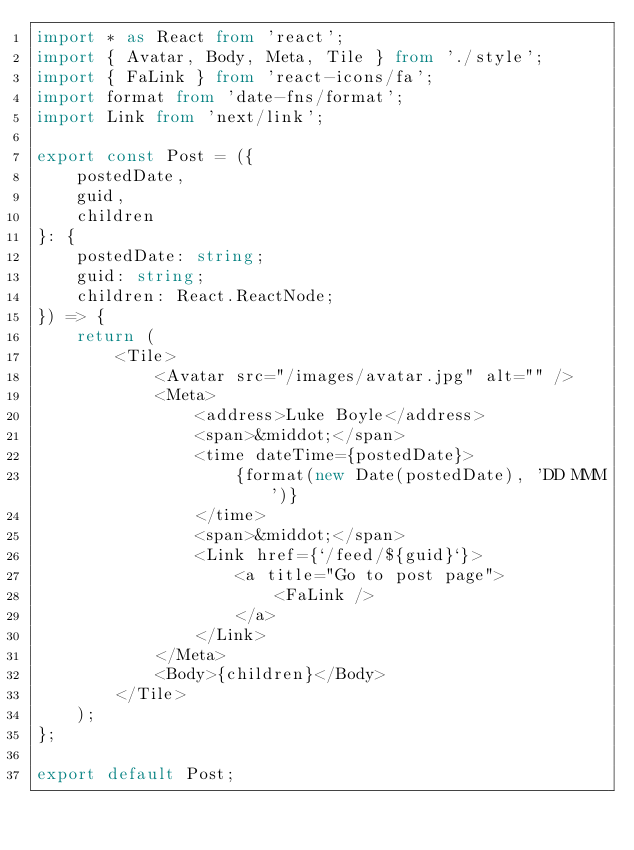<code> <loc_0><loc_0><loc_500><loc_500><_TypeScript_>import * as React from 'react';
import { Avatar, Body, Meta, Tile } from './style';
import { FaLink } from 'react-icons/fa';
import format from 'date-fns/format';
import Link from 'next/link';

export const Post = ({
	postedDate,
	guid,
	children
}: {
	postedDate: string;
	guid: string;
	children: React.ReactNode;
}) => {
	return (
		<Tile>
			<Avatar src="/images/avatar.jpg" alt="" />
			<Meta>
				<address>Luke Boyle</address>
				<span>&middot;</span>
				<time dateTime={postedDate}>
					{format(new Date(postedDate), 'DD MMM')}
				</time>
				<span>&middot;</span>
				<Link href={`/feed/${guid}`}>
					<a title="Go to post page">
						<FaLink />
					</a>
				</Link>
			</Meta>
			<Body>{children}</Body>
		</Tile>
	);
};

export default Post;
</code> 